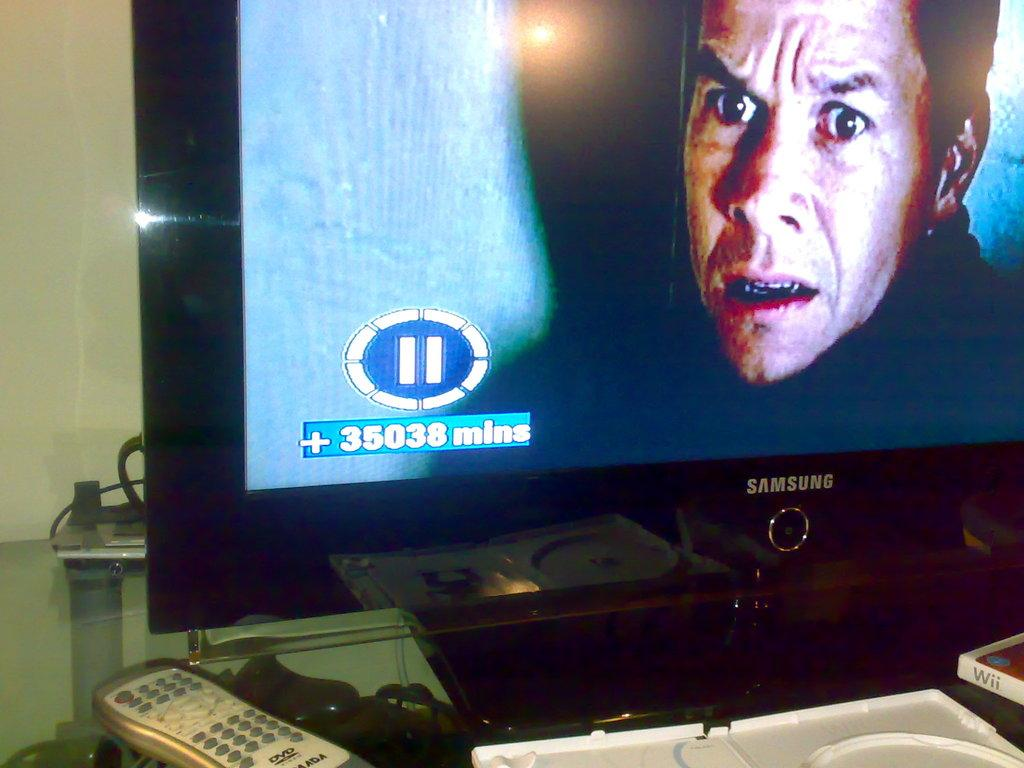<image>
Describe the image concisely. A movie playing on a Samsung tv is paused on 35038 mins. 